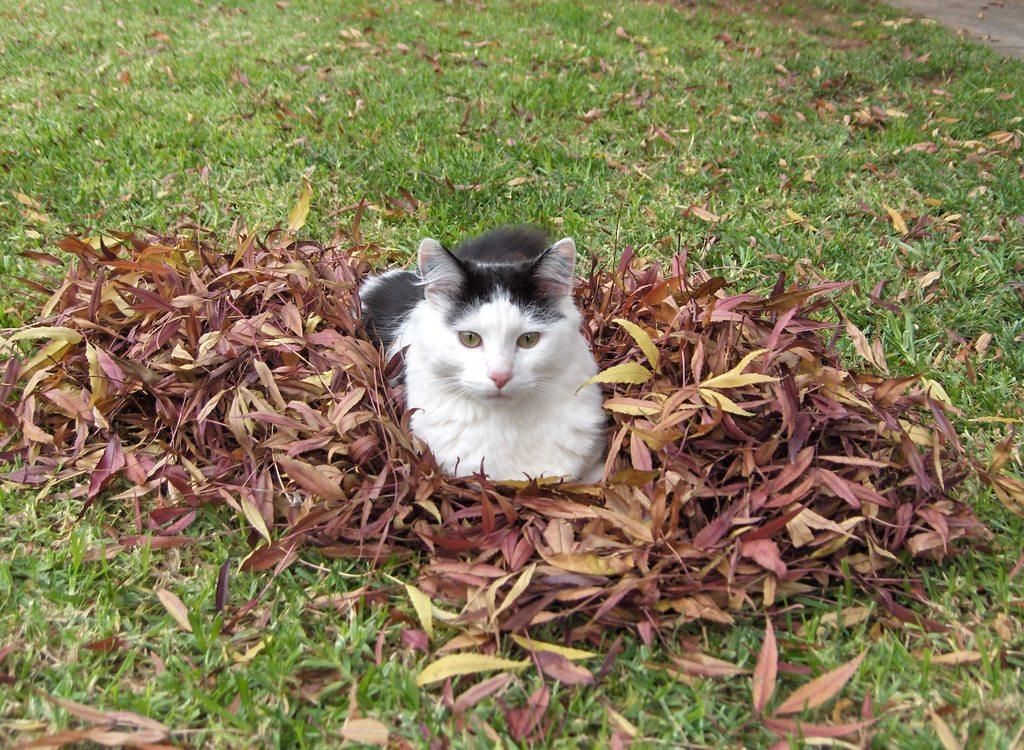What type of vegetation is present on the ground in the image? There is grass on the ground in the image. What animal can be seen sitting on leaves in the image? There is a cat sitting on leaves in the image. What type of pleasure can be heard whistling in the background of the image? There is no indication of any pleasure or background noise in the image, as it only features grass and a cat sitting on leaves. 